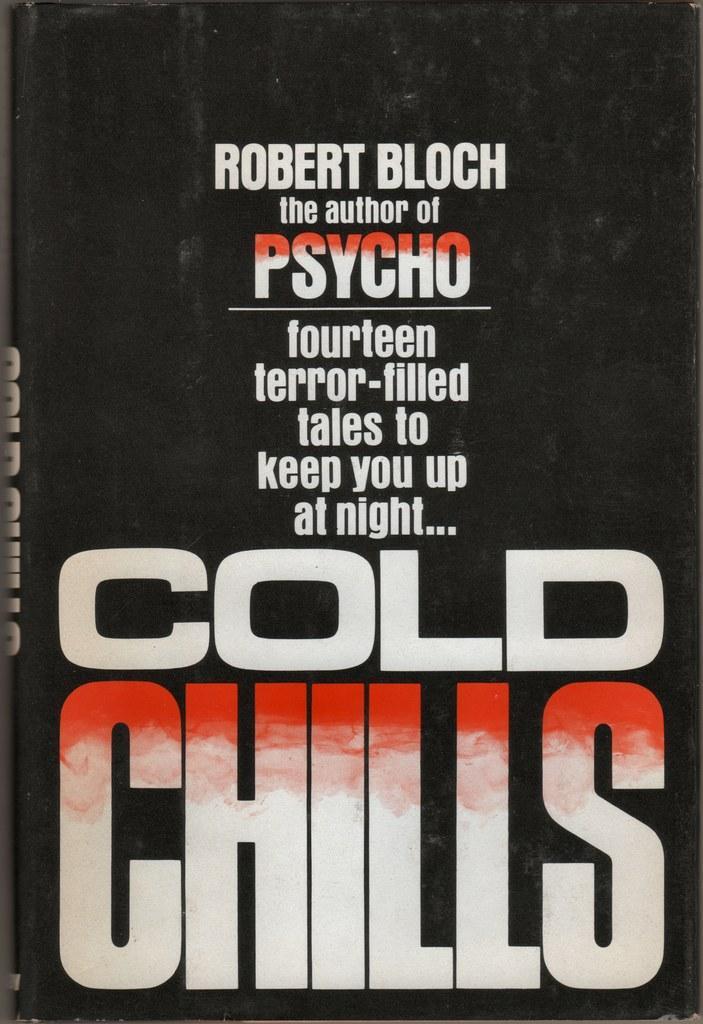How would you summarize this image in a sentence or two? This picture contains a black color thing which looks like a book. We see some text written on this book. 